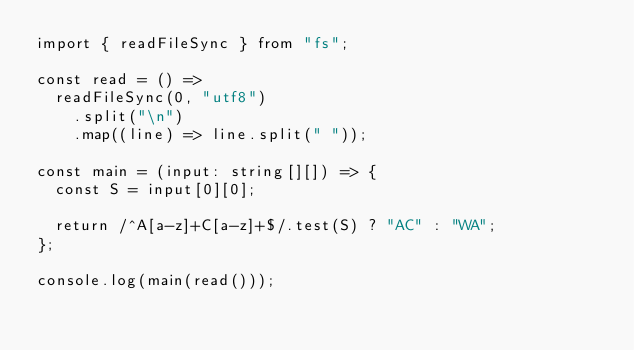Convert code to text. <code><loc_0><loc_0><loc_500><loc_500><_TypeScript_>import { readFileSync } from "fs";

const read = () =>
  readFileSync(0, "utf8")
    .split("\n")
    .map((line) => line.split(" "));

const main = (input: string[][]) => {
  const S = input[0][0];

  return /^A[a-z]+C[a-z]+$/.test(S) ? "AC" : "WA";
};

console.log(main(read()));
</code> 